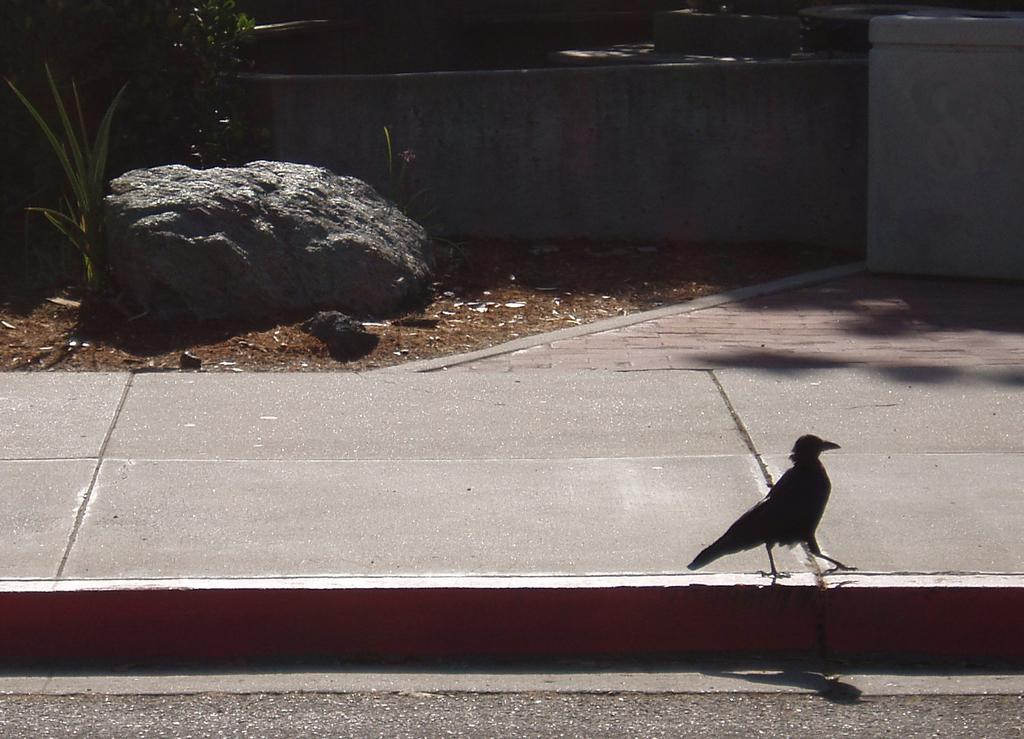What type of animal can be seen in the image? There is a bird in the image. What is the main feature in the center of the image? There is a road in the image, and it is located in the center. What can be seen in the background of the image? There is a wall in the background of the image. What other objects or elements are present in the image? There is a rock and plants in the image. How is the frame of the image being used to transport the bird? The frame of the image is not used for transporting the bird; it is a static representation of the bird and other elements in the scene. 